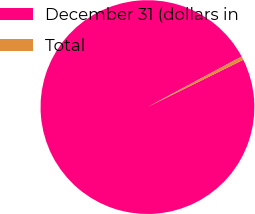Convert chart. <chart><loc_0><loc_0><loc_500><loc_500><pie_chart><fcel>December 31 (dollars in<fcel>Total<nl><fcel>99.45%<fcel>0.55%<nl></chart> 